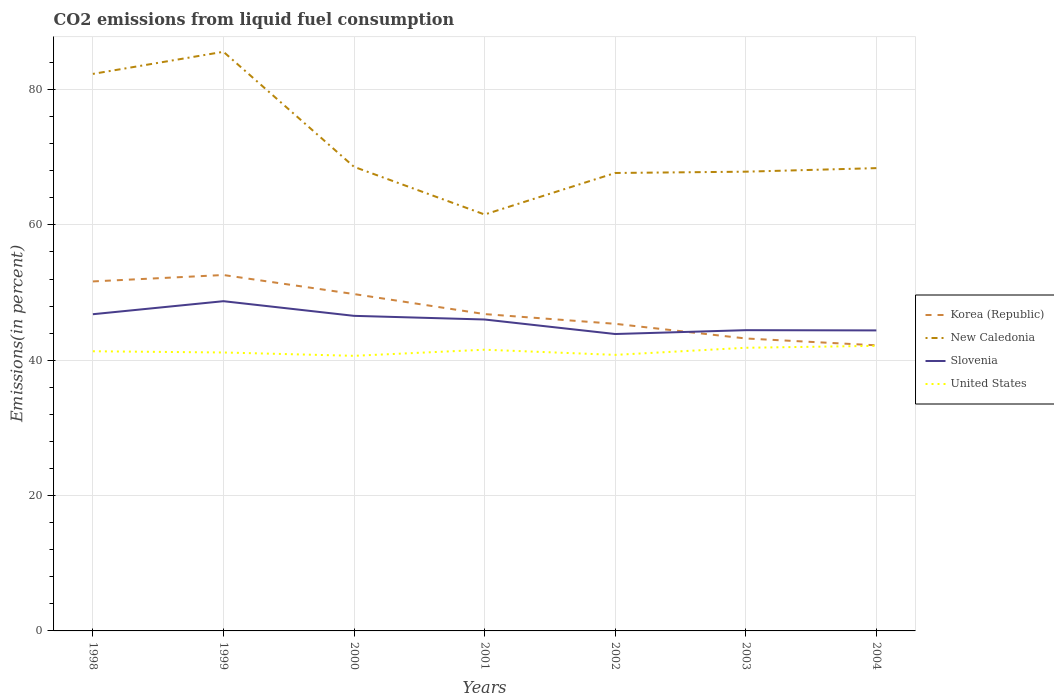Does the line corresponding to United States intersect with the line corresponding to New Caledonia?
Your answer should be compact. No. Is the number of lines equal to the number of legend labels?
Your answer should be very brief. Yes. Across all years, what is the maximum total CO2 emitted in Slovenia?
Make the answer very short. 43.88. What is the total total CO2 emitted in Slovenia in the graph?
Provide a short and direct response. 1.58. What is the difference between the highest and the second highest total CO2 emitted in Slovenia?
Offer a terse response. 4.85. What is the difference between the highest and the lowest total CO2 emitted in New Caledonia?
Offer a very short reply. 2. Is the total CO2 emitted in New Caledonia strictly greater than the total CO2 emitted in United States over the years?
Keep it short and to the point. No. Where does the legend appear in the graph?
Give a very brief answer. Center right. How are the legend labels stacked?
Your response must be concise. Vertical. What is the title of the graph?
Your answer should be compact. CO2 emissions from liquid fuel consumption. What is the label or title of the X-axis?
Provide a short and direct response. Years. What is the label or title of the Y-axis?
Provide a short and direct response. Emissions(in percent). What is the Emissions(in percent) of Korea (Republic) in 1998?
Make the answer very short. 51.65. What is the Emissions(in percent) in New Caledonia in 1998?
Provide a succinct answer. 82.32. What is the Emissions(in percent) of Slovenia in 1998?
Ensure brevity in your answer.  46.8. What is the Emissions(in percent) in United States in 1998?
Offer a terse response. 41.33. What is the Emissions(in percent) in Korea (Republic) in 1999?
Keep it short and to the point. 52.6. What is the Emissions(in percent) of New Caledonia in 1999?
Your answer should be very brief. 85.59. What is the Emissions(in percent) of Slovenia in 1999?
Your answer should be very brief. 48.73. What is the Emissions(in percent) of United States in 1999?
Provide a short and direct response. 41.15. What is the Emissions(in percent) of Korea (Republic) in 2000?
Ensure brevity in your answer.  49.78. What is the Emissions(in percent) of New Caledonia in 2000?
Provide a succinct answer. 68.58. What is the Emissions(in percent) of Slovenia in 2000?
Offer a very short reply. 46.56. What is the Emissions(in percent) of United States in 2000?
Provide a short and direct response. 40.65. What is the Emissions(in percent) in Korea (Republic) in 2001?
Offer a terse response. 46.82. What is the Emissions(in percent) in New Caledonia in 2001?
Ensure brevity in your answer.  61.54. What is the Emissions(in percent) in Slovenia in 2001?
Provide a short and direct response. 46.02. What is the Emissions(in percent) in United States in 2001?
Your answer should be compact. 41.56. What is the Emissions(in percent) in Korea (Republic) in 2002?
Provide a succinct answer. 45.38. What is the Emissions(in percent) of New Caledonia in 2002?
Make the answer very short. 67.67. What is the Emissions(in percent) of Slovenia in 2002?
Make the answer very short. 43.88. What is the Emissions(in percent) of United States in 2002?
Your answer should be very brief. 40.79. What is the Emissions(in percent) in Korea (Republic) in 2003?
Provide a succinct answer. 43.22. What is the Emissions(in percent) of New Caledonia in 2003?
Provide a short and direct response. 67.87. What is the Emissions(in percent) in Slovenia in 2003?
Give a very brief answer. 44.44. What is the Emissions(in percent) in United States in 2003?
Provide a short and direct response. 41.84. What is the Emissions(in percent) of Korea (Republic) in 2004?
Keep it short and to the point. 42.21. What is the Emissions(in percent) in New Caledonia in 2004?
Give a very brief answer. 68.39. What is the Emissions(in percent) of Slovenia in 2004?
Offer a very short reply. 44.41. What is the Emissions(in percent) of United States in 2004?
Provide a succinct answer. 42.13. Across all years, what is the maximum Emissions(in percent) of Korea (Republic)?
Keep it short and to the point. 52.6. Across all years, what is the maximum Emissions(in percent) of New Caledonia?
Offer a terse response. 85.59. Across all years, what is the maximum Emissions(in percent) in Slovenia?
Your answer should be very brief. 48.73. Across all years, what is the maximum Emissions(in percent) of United States?
Offer a terse response. 42.13. Across all years, what is the minimum Emissions(in percent) in Korea (Republic)?
Your answer should be very brief. 42.21. Across all years, what is the minimum Emissions(in percent) in New Caledonia?
Keep it short and to the point. 61.54. Across all years, what is the minimum Emissions(in percent) in Slovenia?
Ensure brevity in your answer.  43.88. Across all years, what is the minimum Emissions(in percent) in United States?
Make the answer very short. 40.65. What is the total Emissions(in percent) in Korea (Republic) in the graph?
Give a very brief answer. 331.66. What is the total Emissions(in percent) in New Caledonia in the graph?
Provide a short and direct response. 501.95. What is the total Emissions(in percent) of Slovenia in the graph?
Give a very brief answer. 320.84. What is the total Emissions(in percent) of United States in the graph?
Your answer should be very brief. 289.46. What is the difference between the Emissions(in percent) of Korea (Republic) in 1998 and that in 1999?
Offer a very short reply. -0.95. What is the difference between the Emissions(in percent) in New Caledonia in 1998 and that in 1999?
Your response must be concise. -3.27. What is the difference between the Emissions(in percent) of Slovenia in 1998 and that in 1999?
Offer a terse response. -1.93. What is the difference between the Emissions(in percent) in United States in 1998 and that in 1999?
Your answer should be compact. 0.18. What is the difference between the Emissions(in percent) of Korea (Republic) in 1998 and that in 2000?
Ensure brevity in your answer.  1.87. What is the difference between the Emissions(in percent) of New Caledonia in 1998 and that in 2000?
Provide a succinct answer. 13.74. What is the difference between the Emissions(in percent) of Slovenia in 1998 and that in 2000?
Offer a very short reply. 0.24. What is the difference between the Emissions(in percent) in United States in 1998 and that in 2000?
Ensure brevity in your answer.  0.67. What is the difference between the Emissions(in percent) in Korea (Republic) in 1998 and that in 2001?
Provide a short and direct response. 4.83. What is the difference between the Emissions(in percent) of New Caledonia in 1998 and that in 2001?
Your response must be concise. 20.78. What is the difference between the Emissions(in percent) of Slovenia in 1998 and that in 2001?
Your answer should be compact. 0.78. What is the difference between the Emissions(in percent) in United States in 1998 and that in 2001?
Offer a terse response. -0.23. What is the difference between the Emissions(in percent) of Korea (Republic) in 1998 and that in 2002?
Provide a short and direct response. 6.26. What is the difference between the Emissions(in percent) of New Caledonia in 1998 and that in 2002?
Offer a very short reply. 14.64. What is the difference between the Emissions(in percent) in Slovenia in 1998 and that in 2002?
Offer a very short reply. 2.93. What is the difference between the Emissions(in percent) in United States in 1998 and that in 2002?
Your response must be concise. 0.53. What is the difference between the Emissions(in percent) in Korea (Republic) in 1998 and that in 2003?
Your answer should be compact. 8.43. What is the difference between the Emissions(in percent) in New Caledonia in 1998 and that in 2003?
Ensure brevity in your answer.  14.45. What is the difference between the Emissions(in percent) in Slovenia in 1998 and that in 2003?
Ensure brevity in your answer.  2.36. What is the difference between the Emissions(in percent) of United States in 1998 and that in 2003?
Your response must be concise. -0.52. What is the difference between the Emissions(in percent) of Korea (Republic) in 1998 and that in 2004?
Your response must be concise. 9.44. What is the difference between the Emissions(in percent) of New Caledonia in 1998 and that in 2004?
Your answer should be very brief. 13.93. What is the difference between the Emissions(in percent) in Slovenia in 1998 and that in 2004?
Your answer should be compact. 2.39. What is the difference between the Emissions(in percent) in United States in 1998 and that in 2004?
Your response must be concise. -0.8. What is the difference between the Emissions(in percent) of Korea (Republic) in 1999 and that in 2000?
Offer a very short reply. 2.82. What is the difference between the Emissions(in percent) of New Caledonia in 1999 and that in 2000?
Keep it short and to the point. 17. What is the difference between the Emissions(in percent) of Slovenia in 1999 and that in 2000?
Provide a succinct answer. 2.17. What is the difference between the Emissions(in percent) in United States in 1999 and that in 2000?
Make the answer very short. 0.49. What is the difference between the Emissions(in percent) in Korea (Republic) in 1999 and that in 2001?
Offer a terse response. 5.77. What is the difference between the Emissions(in percent) in New Caledonia in 1999 and that in 2001?
Give a very brief answer. 24.05. What is the difference between the Emissions(in percent) in Slovenia in 1999 and that in 2001?
Provide a short and direct response. 2.71. What is the difference between the Emissions(in percent) in United States in 1999 and that in 2001?
Ensure brevity in your answer.  -0.41. What is the difference between the Emissions(in percent) in Korea (Republic) in 1999 and that in 2002?
Your response must be concise. 7.21. What is the difference between the Emissions(in percent) of New Caledonia in 1999 and that in 2002?
Your answer should be very brief. 17.91. What is the difference between the Emissions(in percent) in Slovenia in 1999 and that in 2002?
Give a very brief answer. 4.85. What is the difference between the Emissions(in percent) in United States in 1999 and that in 2002?
Keep it short and to the point. 0.35. What is the difference between the Emissions(in percent) of Korea (Republic) in 1999 and that in 2003?
Your answer should be compact. 9.38. What is the difference between the Emissions(in percent) of New Caledonia in 1999 and that in 2003?
Give a very brief answer. 17.72. What is the difference between the Emissions(in percent) of Slovenia in 1999 and that in 2003?
Your answer should be very brief. 4.28. What is the difference between the Emissions(in percent) of United States in 1999 and that in 2003?
Your answer should be compact. -0.7. What is the difference between the Emissions(in percent) of Korea (Republic) in 1999 and that in 2004?
Provide a succinct answer. 10.39. What is the difference between the Emissions(in percent) of New Caledonia in 1999 and that in 2004?
Make the answer very short. 17.19. What is the difference between the Emissions(in percent) in Slovenia in 1999 and that in 2004?
Your response must be concise. 4.32. What is the difference between the Emissions(in percent) in United States in 1999 and that in 2004?
Keep it short and to the point. -0.98. What is the difference between the Emissions(in percent) of Korea (Republic) in 2000 and that in 2001?
Give a very brief answer. 2.96. What is the difference between the Emissions(in percent) in New Caledonia in 2000 and that in 2001?
Your response must be concise. 7.04. What is the difference between the Emissions(in percent) in Slovenia in 2000 and that in 2001?
Ensure brevity in your answer.  0.54. What is the difference between the Emissions(in percent) in United States in 2000 and that in 2001?
Your answer should be very brief. -0.9. What is the difference between the Emissions(in percent) of Korea (Republic) in 2000 and that in 2002?
Your response must be concise. 4.4. What is the difference between the Emissions(in percent) in New Caledonia in 2000 and that in 2002?
Your answer should be very brief. 0.91. What is the difference between the Emissions(in percent) of Slovenia in 2000 and that in 2002?
Ensure brevity in your answer.  2.69. What is the difference between the Emissions(in percent) in United States in 2000 and that in 2002?
Offer a very short reply. -0.14. What is the difference between the Emissions(in percent) of Korea (Republic) in 2000 and that in 2003?
Provide a short and direct response. 6.56. What is the difference between the Emissions(in percent) of New Caledonia in 2000 and that in 2003?
Offer a terse response. 0.71. What is the difference between the Emissions(in percent) in Slovenia in 2000 and that in 2003?
Your response must be concise. 2.12. What is the difference between the Emissions(in percent) of United States in 2000 and that in 2003?
Keep it short and to the point. -1.19. What is the difference between the Emissions(in percent) in Korea (Republic) in 2000 and that in 2004?
Keep it short and to the point. 7.57. What is the difference between the Emissions(in percent) in New Caledonia in 2000 and that in 2004?
Provide a short and direct response. 0.19. What is the difference between the Emissions(in percent) in Slovenia in 2000 and that in 2004?
Provide a succinct answer. 2.15. What is the difference between the Emissions(in percent) of United States in 2000 and that in 2004?
Make the answer very short. -1.48. What is the difference between the Emissions(in percent) in Korea (Republic) in 2001 and that in 2002?
Your answer should be compact. 1.44. What is the difference between the Emissions(in percent) of New Caledonia in 2001 and that in 2002?
Provide a succinct answer. -6.14. What is the difference between the Emissions(in percent) of Slovenia in 2001 and that in 2002?
Offer a very short reply. 2.15. What is the difference between the Emissions(in percent) of United States in 2001 and that in 2002?
Offer a very short reply. 0.76. What is the difference between the Emissions(in percent) in Korea (Republic) in 2001 and that in 2003?
Offer a very short reply. 3.6. What is the difference between the Emissions(in percent) of New Caledonia in 2001 and that in 2003?
Offer a very short reply. -6.33. What is the difference between the Emissions(in percent) in Slovenia in 2001 and that in 2003?
Your answer should be compact. 1.58. What is the difference between the Emissions(in percent) in United States in 2001 and that in 2003?
Make the answer very short. -0.29. What is the difference between the Emissions(in percent) of Korea (Republic) in 2001 and that in 2004?
Offer a terse response. 4.61. What is the difference between the Emissions(in percent) of New Caledonia in 2001 and that in 2004?
Provide a succinct answer. -6.85. What is the difference between the Emissions(in percent) of Slovenia in 2001 and that in 2004?
Make the answer very short. 1.61. What is the difference between the Emissions(in percent) of United States in 2001 and that in 2004?
Make the answer very short. -0.57. What is the difference between the Emissions(in percent) in Korea (Republic) in 2002 and that in 2003?
Make the answer very short. 2.17. What is the difference between the Emissions(in percent) in New Caledonia in 2002 and that in 2003?
Keep it short and to the point. -0.19. What is the difference between the Emissions(in percent) of Slovenia in 2002 and that in 2003?
Offer a very short reply. -0.57. What is the difference between the Emissions(in percent) of United States in 2002 and that in 2003?
Offer a terse response. -1.05. What is the difference between the Emissions(in percent) in Korea (Republic) in 2002 and that in 2004?
Give a very brief answer. 3.18. What is the difference between the Emissions(in percent) of New Caledonia in 2002 and that in 2004?
Provide a succinct answer. -0.72. What is the difference between the Emissions(in percent) of Slovenia in 2002 and that in 2004?
Provide a short and direct response. -0.53. What is the difference between the Emissions(in percent) of United States in 2002 and that in 2004?
Ensure brevity in your answer.  -1.34. What is the difference between the Emissions(in percent) in New Caledonia in 2003 and that in 2004?
Ensure brevity in your answer.  -0.52. What is the difference between the Emissions(in percent) of Slovenia in 2003 and that in 2004?
Your response must be concise. 0.03. What is the difference between the Emissions(in percent) in United States in 2003 and that in 2004?
Offer a terse response. -0.29. What is the difference between the Emissions(in percent) of Korea (Republic) in 1998 and the Emissions(in percent) of New Caledonia in 1999?
Provide a succinct answer. -33.94. What is the difference between the Emissions(in percent) of Korea (Republic) in 1998 and the Emissions(in percent) of Slovenia in 1999?
Make the answer very short. 2.92. What is the difference between the Emissions(in percent) in Korea (Republic) in 1998 and the Emissions(in percent) in United States in 1999?
Provide a short and direct response. 10.5. What is the difference between the Emissions(in percent) of New Caledonia in 1998 and the Emissions(in percent) of Slovenia in 1999?
Provide a short and direct response. 33.59. What is the difference between the Emissions(in percent) in New Caledonia in 1998 and the Emissions(in percent) in United States in 1999?
Give a very brief answer. 41.17. What is the difference between the Emissions(in percent) of Slovenia in 1998 and the Emissions(in percent) of United States in 1999?
Your answer should be compact. 5.65. What is the difference between the Emissions(in percent) of Korea (Republic) in 1998 and the Emissions(in percent) of New Caledonia in 2000?
Offer a terse response. -16.93. What is the difference between the Emissions(in percent) in Korea (Republic) in 1998 and the Emissions(in percent) in Slovenia in 2000?
Your response must be concise. 5.09. What is the difference between the Emissions(in percent) of Korea (Republic) in 1998 and the Emissions(in percent) of United States in 2000?
Provide a succinct answer. 10.99. What is the difference between the Emissions(in percent) in New Caledonia in 1998 and the Emissions(in percent) in Slovenia in 2000?
Give a very brief answer. 35.76. What is the difference between the Emissions(in percent) in New Caledonia in 1998 and the Emissions(in percent) in United States in 2000?
Your response must be concise. 41.66. What is the difference between the Emissions(in percent) in Slovenia in 1998 and the Emissions(in percent) in United States in 2000?
Keep it short and to the point. 6.15. What is the difference between the Emissions(in percent) of Korea (Republic) in 1998 and the Emissions(in percent) of New Caledonia in 2001?
Keep it short and to the point. -9.89. What is the difference between the Emissions(in percent) in Korea (Republic) in 1998 and the Emissions(in percent) in Slovenia in 2001?
Provide a succinct answer. 5.63. What is the difference between the Emissions(in percent) of Korea (Republic) in 1998 and the Emissions(in percent) of United States in 2001?
Offer a terse response. 10.09. What is the difference between the Emissions(in percent) of New Caledonia in 1998 and the Emissions(in percent) of Slovenia in 2001?
Keep it short and to the point. 36.3. What is the difference between the Emissions(in percent) in New Caledonia in 1998 and the Emissions(in percent) in United States in 2001?
Provide a short and direct response. 40.76. What is the difference between the Emissions(in percent) of Slovenia in 1998 and the Emissions(in percent) of United States in 2001?
Your answer should be compact. 5.24. What is the difference between the Emissions(in percent) of Korea (Republic) in 1998 and the Emissions(in percent) of New Caledonia in 2002?
Provide a short and direct response. -16.02. What is the difference between the Emissions(in percent) in Korea (Republic) in 1998 and the Emissions(in percent) in Slovenia in 2002?
Your response must be concise. 7.77. What is the difference between the Emissions(in percent) in Korea (Republic) in 1998 and the Emissions(in percent) in United States in 2002?
Keep it short and to the point. 10.85. What is the difference between the Emissions(in percent) of New Caledonia in 1998 and the Emissions(in percent) of Slovenia in 2002?
Give a very brief answer. 38.44. What is the difference between the Emissions(in percent) of New Caledonia in 1998 and the Emissions(in percent) of United States in 2002?
Provide a succinct answer. 41.52. What is the difference between the Emissions(in percent) in Slovenia in 1998 and the Emissions(in percent) in United States in 2002?
Give a very brief answer. 6.01. What is the difference between the Emissions(in percent) in Korea (Republic) in 1998 and the Emissions(in percent) in New Caledonia in 2003?
Offer a very short reply. -16.22. What is the difference between the Emissions(in percent) in Korea (Republic) in 1998 and the Emissions(in percent) in Slovenia in 2003?
Your answer should be very brief. 7.2. What is the difference between the Emissions(in percent) in Korea (Republic) in 1998 and the Emissions(in percent) in United States in 2003?
Ensure brevity in your answer.  9.8. What is the difference between the Emissions(in percent) of New Caledonia in 1998 and the Emissions(in percent) of Slovenia in 2003?
Offer a terse response. 37.87. What is the difference between the Emissions(in percent) of New Caledonia in 1998 and the Emissions(in percent) of United States in 2003?
Make the answer very short. 40.47. What is the difference between the Emissions(in percent) of Slovenia in 1998 and the Emissions(in percent) of United States in 2003?
Provide a succinct answer. 4.96. What is the difference between the Emissions(in percent) in Korea (Republic) in 1998 and the Emissions(in percent) in New Caledonia in 2004?
Keep it short and to the point. -16.74. What is the difference between the Emissions(in percent) in Korea (Republic) in 1998 and the Emissions(in percent) in Slovenia in 2004?
Offer a very short reply. 7.24. What is the difference between the Emissions(in percent) in Korea (Republic) in 1998 and the Emissions(in percent) in United States in 2004?
Provide a succinct answer. 9.52. What is the difference between the Emissions(in percent) of New Caledonia in 1998 and the Emissions(in percent) of Slovenia in 2004?
Your answer should be compact. 37.91. What is the difference between the Emissions(in percent) in New Caledonia in 1998 and the Emissions(in percent) in United States in 2004?
Your answer should be compact. 40.19. What is the difference between the Emissions(in percent) of Slovenia in 1998 and the Emissions(in percent) of United States in 2004?
Ensure brevity in your answer.  4.67. What is the difference between the Emissions(in percent) in Korea (Republic) in 1999 and the Emissions(in percent) in New Caledonia in 2000?
Your response must be concise. -15.98. What is the difference between the Emissions(in percent) in Korea (Republic) in 1999 and the Emissions(in percent) in Slovenia in 2000?
Provide a short and direct response. 6.03. What is the difference between the Emissions(in percent) of Korea (Republic) in 1999 and the Emissions(in percent) of United States in 2000?
Offer a terse response. 11.94. What is the difference between the Emissions(in percent) of New Caledonia in 1999 and the Emissions(in percent) of Slovenia in 2000?
Give a very brief answer. 39.02. What is the difference between the Emissions(in percent) of New Caledonia in 1999 and the Emissions(in percent) of United States in 2000?
Your answer should be very brief. 44.93. What is the difference between the Emissions(in percent) in Slovenia in 1999 and the Emissions(in percent) in United States in 2000?
Offer a terse response. 8.07. What is the difference between the Emissions(in percent) of Korea (Republic) in 1999 and the Emissions(in percent) of New Caledonia in 2001?
Your response must be concise. -8.94. What is the difference between the Emissions(in percent) in Korea (Republic) in 1999 and the Emissions(in percent) in Slovenia in 2001?
Keep it short and to the point. 6.57. What is the difference between the Emissions(in percent) of Korea (Republic) in 1999 and the Emissions(in percent) of United States in 2001?
Your answer should be very brief. 11.04. What is the difference between the Emissions(in percent) of New Caledonia in 1999 and the Emissions(in percent) of Slovenia in 2001?
Provide a short and direct response. 39.56. What is the difference between the Emissions(in percent) of New Caledonia in 1999 and the Emissions(in percent) of United States in 2001?
Provide a short and direct response. 44.03. What is the difference between the Emissions(in percent) of Slovenia in 1999 and the Emissions(in percent) of United States in 2001?
Offer a very short reply. 7.17. What is the difference between the Emissions(in percent) in Korea (Republic) in 1999 and the Emissions(in percent) in New Caledonia in 2002?
Give a very brief answer. -15.08. What is the difference between the Emissions(in percent) in Korea (Republic) in 1999 and the Emissions(in percent) in Slovenia in 2002?
Your answer should be very brief. 8.72. What is the difference between the Emissions(in percent) in Korea (Republic) in 1999 and the Emissions(in percent) in United States in 2002?
Provide a short and direct response. 11.8. What is the difference between the Emissions(in percent) in New Caledonia in 1999 and the Emissions(in percent) in Slovenia in 2002?
Provide a short and direct response. 41.71. What is the difference between the Emissions(in percent) of New Caledonia in 1999 and the Emissions(in percent) of United States in 2002?
Your answer should be very brief. 44.79. What is the difference between the Emissions(in percent) in Slovenia in 1999 and the Emissions(in percent) in United States in 2002?
Offer a terse response. 7.93. What is the difference between the Emissions(in percent) in Korea (Republic) in 1999 and the Emissions(in percent) in New Caledonia in 2003?
Offer a terse response. -15.27. What is the difference between the Emissions(in percent) of Korea (Republic) in 1999 and the Emissions(in percent) of Slovenia in 2003?
Provide a short and direct response. 8.15. What is the difference between the Emissions(in percent) of Korea (Republic) in 1999 and the Emissions(in percent) of United States in 2003?
Offer a very short reply. 10.75. What is the difference between the Emissions(in percent) of New Caledonia in 1999 and the Emissions(in percent) of Slovenia in 2003?
Offer a very short reply. 41.14. What is the difference between the Emissions(in percent) in New Caledonia in 1999 and the Emissions(in percent) in United States in 2003?
Provide a short and direct response. 43.74. What is the difference between the Emissions(in percent) in Slovenia in 1999 and the Emissions(in percent) in United States in 2003?
Offer a terse response. 6.88. What is the difference between the Emissions(in percent) in Korea (Republic) in 1999 and the Emissions(in percent) in New Caledonia in 2004?
Offer a very short reply. -15.79. What is the difference between the Emissions(in percent) of Korea (Republic) in 1999 and the Emissions(in percent) of Slovenia in 2004?
Your answer should be compact. 8.19. What is the difference between the Emissions(in percent) of Korea (Republic) in 1999 and the Emissions(in percent) of United States in 2004?
Provide a short and direct response. 10.47. What is the difference between the Emissions(in percent) in New Caledonia in 1999 and the Emissions(in percent) in Slovenia in 2004?
Provide a short and direct response. 41.17. What is the difference between the Emissions(in percent) of New Caledonia in 1999 and the Emissions(in percent) of United States in 2004?
Make the answer very short. 43.46. What is the difference between the Emissions(in percent) in Slovenia in 1999 and the Emissions(in percent) in United States in 2004?
Make the answer very short. 6.6. What is the difference between the Emissions(in percent) in Korea (Republic) in 2000 and the Emissions(in percent) in New Caledonia in 2001?
Keep it short and to the point. -11.76. What is the difference between the Emissions(in percent) in Korea (Republic) in 2000 and the Emissions(in percent) in Slovenia in 2001?
Your response must be concise. 3.76. What is the difference between the Emissions(in percent) in Korea (Republic) in 2000 and the Emissions(in percent) in United States in 2001?
Make the answer very short. 8.22. What is the difference between the Emissions(in percent) of New Caledonia in 2000 and the Emissions(in percent) of Slovenia in 2001?
Offer a terse response. 22.56. What is the difference between the Emissions(in percent) of New Caledonia in 2000 and the Emissions(in percent) of United States in 2001?
Offer a very short reply. 27.02. What is the difference between the Emissions(in percent) in Slovenia in 2000 and the Emissions(in percent) in United States in 2001?
Your response must be concise. 5. What is the difference between the Emissions(in percent) in Korea (Republic) in 2000 and the Emissions(in percent) in New Caledonia in 2002?
Your answer should be very brief. -17.89. What is the difference between the Emissions(in percent) of Korea (Republic) in 2000 and the Emissions(in percent) of Slovenia in 2002?
Offer a terse response. 5.9. What is the difference between the Emissions(in percent) in Korea (Republic) in 2000 and the Emissions(in percent) in United States in 2002?
Keep it short and to the point. 8.99. What is the difference between the Emissions(in percent) in New Caledonia in 2000 and the Emissions(in percent) in Slovenia in 2002?
Offer a very short reply. 24.7. What is the difference between the Emissions(in percent) in New Caledonia in 2000 and the Emissions(in percent) in United States in 2002?
Your answer should be very brief. 27.79. What is the difference between the Emissions(in percent) in Slovenia in 2000 and the Emissions(in percent) in United States in 2002?
Ensure brevity in your answer.  5.77. What is the difference between the Emissions(in percent) of Korea (Republic) in 2000 and the Emissions(in percent) of New Caledonia in 2003?
Your answer should be compact. -18.09. What is the difference between the Emissions(in percent) of Korea (Republic) in 2000 and the Emissions(in percent) of Slovenia in 2003?
Keep it short and to the point. 5.34. What is the difference between the Emissions(in percent) of Korea (Republic) in 2000 and the Emissions(in percent) of United States in 2003?
Your answer should be very brief. 7.94. What is the difference between the Emissions(in percent) in New Caledonia in 2000 and the Emissions(in percent) in Slovenia in 2003?
Offer a very short reply. 24.14. What is the difference between the Emissions(in percent) of New Caledonia in 2000 and the Emissions(in percent) of United States in 2003?
Offer a very short reply. 26.74. What is the difference between the Emissions(in percent) of Slovenia in 2000 and the Emissions(in percent) of United States in 2003?
Offer a very short reply. 4.72. What is the difference between the Emissions(in percent) of Korea (Republic) in 2000 and the Emissions(in percent) of New Caledonia in 2004?
Offer a terse response. -18.61. What is the difference between the Emissions(in percent) of Korea (Republic) in 2000 and the Emissions(in percent) of Slovenia in 2004?
Offer a terse response. 5.37. What is the difference between the Emissions(in percent) in Korea (Republic) in 2000 and the Emissions(in percent) in United States in 2004?
Give a very brief answer. 7.65. What is the difference between the Emissions(in percent) in New Caledonia in 2000 and the Emissions(in percent) in Slovenia in 2004?
Offer a very short reply. 24.17. What is the difference between the Emissions(in percent) in New Caledonia in 2000 and the Emissions(in percent) in United States in 2004?
Provide a succinct answer. 26.45. What is the difference between the Emissions(in percent) in Slovenia in 2000 and the Emissions(in percent) in United States in 2004?
Your response must be concise. 4.43. What is the difference between the Emissions(in percent) in Korea (Republic) in 2001 and the Emissions(in percent) in New Caledonia in 2002?
Ensure brevity in your answer.  -20.85. What is the difference between the Emissions(in percent) of Korea (Republic) in 2001 and the Emissions(in percent) of Slovenia in 2002?
Your answer should be very brief. 2.94. What is the difference between the Emissions(in percent) in Korea (Republic) in 2001 and the Emissions(in percent) in United States in 2002?
Ensure brevity in your answer.  6.03. What is the difference between the Emissions(in percent) in New Caledonia in 2001 and the Emissions(in percent) in Slovenia in 2002?
Keep it short and to the point. 17.66. What is the difference between the Emissions(in percent) in New Caledonia in 2001 and the Emissions(in percent) in United States in 2002?
Offer a very short reply. 20.74. What is the difference between the Emissions(in percent) of Slovenia in 2001 and the Emissions(in percent) of United States in 2002?
Make the answer very short. 5.23. What is the difference between the Emissions(in percent) of Korea (Republic) in 2001 and the Emissions(in percent) of New Caledonia in 2003?
Provide a succinct answer. -21.05. What is the difference between the Emissions(in percent) of Korea (Republic) in 2001 and the Emissions(in percent) of Slovenia in 2003?
Your answer should be very brief. 2.38. What is the difference between the Emissions(in percent) in Korea (Republic) in 2001 and the Emissions(in percent) in United States in 2003?
Your answer should be compact. 4.98. What is the difference between the Emissions(in percent) of New Caledonia in 2001 and the Emissions(in percent) of Slovenia in 2003?
Provide a succinct answer. 17.09. What is the difference between the Emissions(in percent) of New Caledonia in 2001 and the Emissions(in percent) of United States in 2003?
Offer a very short reply. 19.69. What is the difference between the Emissions(in percent) in Slovenia in 2001 and the Emissions(in percent) in United States in 2003?
Offer a very short reply. 4.18. What is the difference between the Emissions(in percent) of Korea (Republic) in 2001 and the Emissions(in percent) of New Caledonia in 2004?
Your response must be concise. -21.57. What is the difference between the Emissions(in percent) in Korea (Republic) in 2001 and the Emissions(in percent) in Slovenia in 2004?
Keep it short and to the point. 2.41. What is the difference between the Emissions(in percent) in Korea (Republic) in 2001 and the Emissions(in percent) in United States in 2004?
Make the answer very short. 4.69. What is the difference between the Emissions(in percent) in New Caledonia in 2001 and the Emissions(in percent) in Slovenia in 2004?
Offer a very short reply. 17.13. What is the difference between the Emissions(in percent) of New Caledonia in 2001 and the Emissions(in percent) of United States in 2004?
Offer a terse response. 19.41. What is the difference between the Emissions(in percent) of Slovenia in 2001 and the Emissions(in percent) of United States in 2004?
Your response must be concise. 3.89. What is the difference between the Emissions(in percent) of Korea (Republic) in 2002 and the Emissions(in percent) of New Caledonia in 2003?
Offer a terse response. -22.48. What is the difference between the Emissions(in percent) in Korea (Republic) in 2002 and the Emissions(in percent) in Slovenia in 2003?
Your answer should be very brief. 0.94. What is the difference between the Emissions(in percent) of Korea (Republic) in 2002 and the Emissions(in percent) of United States in 2003?
Ensure brevity in your answer.  3.54. What is the difference between the Emissions(in percent) of New Caledonia in 2002 and the Emissions(in percent) of Slovenia in 2003?
Keep it short and to the point. 23.23. What is the difference between the Emissions(in percent) in New Caledonia in 2002 and the Emissions(in percent) in United States in 2003?
Provide a short and direct response. 25.83. What is the difference between the Emissions(in percent) of Slovenia in 2002 and the Emissions(in percent) of United States in 2003?
Keep it short and to the point. 2.03. What is the difference between the Emissions(in percent) in Korea (Republic) in 2002 and the Emissions(in percent) in New Caledonia in 2004?
Your answer should be compact. -23.01. What is the difference between the Emissions(in percent) of Korea (Republic) in 2002 and the Emissions(in percent) of Slovenia in 2004?
Keep it short and to the point. 0.97. What is the difference between the Emissions(in percent) in Korea (Republic) in 2002 and the Emissions(in percent) in United States in 2004?
Keep it short and to the point. 3.25. What is the difference between the Emissions(in percent) in New Caledonia in 2002 and the Emissions(in percent) in Slovenia in 2004?
Your answer should be compact. 23.26. What is the difference between the Emissions(in percent) of New Caledonia in 2002 and the Emissions(in percent) of United States in 2004?
Keep it short and to the point. 25.54. What is the difference between the Emissions(in percent) of Slovenia in 2002 and the Emissions(in percent) of United States in 2004?
Your answer should be very brief. 1.75. What is the difference between the Emissions(in percent) of Korea (Republic) in 2003 and the Emissions(in percent) of New Caledonia in 2004?
Give a very brief answer. -25.17. What is the difference between the Emissions(in percent) of Korea (Republic) in 2003 and the Emissions(in percent) of Slovenia in 2004?
Offer a very short reply. -1.19. What is the difference between the Emissions(in percent) in Korea (Republic) in 2003 and the Emissions(in percent) in United States in 2004?
Provide a succinct answer. 1.09. What is the difference between the Emissions(in percent) in New Caledonia in 2003 and the Emissions(in percent) in Slovenia in 2004?
Provide a succinct answer. 23.46. What is the difference between the Emissions(in percent) in New Caledonia in 2003 and the Emissions(in percent) in United States in 2004?
Provide a short and direct response. 25.74. What is the difference between the Emissions(in percent) in Slovenia in 2003 and the Emissions(in percent) in United States in 2004?
Offer a very short reply. 2.31. What is the average Emissions(in percent) of Korea (Republic) per year?
Give a very brief answer. 47.38. What is the average Emissions(in percent) in New Caledonia per year?
Keep it short and to the point. 71.71. What is the average Emissions(in percent) in Slovenia per year?
Your response must be concise. 45.83. What is the average Emissions(in percent) in United States per year?
Your answer should be compact. 41.35. In the year 1998, what is the difference between the Emissions(in percent) of Korea (Republic) and Emissions(in percent) of New Caledonia?
Give a very brief answer. -30.67. In the year 1998, what is the difference between the Emissions(in percent) of Korea (Republic) and Emissions(in percent) of Slovenia?
Your answer should be very brief. 4.85. In the year 1998, what is the difference between the Emissions(in percent) of Korea (Republic) and Emissions(in percent) of United States?
Ensure brevity in your answer.  10.32. In the year 1998, what is the difference between the Emissions(in percent) of New Caledonia and Emissions(in percent) of Slovenia?
Offer a terse response. 35.52. In the year 1998, what is the difference between the Emissions(in percent) of New Caledonia and Emissions(in percent) of United States?
Keep it short and to the point. 40.99. In the year 1998, what is the difference between the Emissions(in percent) of Slovenia and Emissions(in percent) of United States?
Provide a succinct answer. 5.47. In the year 1999, what is the difference between the Emissions(in percent) in Korea (Republic) and Emissions(in percent) in New Caledonia?
Keep it short and to the point. -32.99. In the year 1999, what is the difference between the Emissions(in percent) in Korea (Republic) and Emissions(in percent) in Slovenia?
Make the answer very short. 3.87. In the year 1999, what is the difference between the Emissions(in percent) of Korea (Republic) and Emissions(in percent) of United States?
Provide a short and direct response. 11.45. In the year 1999, what is the difference between the Emissions(in percent) of New Caledonia and Emissions(in percent) of Slovenia?
Offer a very short reply. 36.86. In the year 1999, what is the difference between the Emissions(in percent) of New Caledonia and Emissions(in percent) of United States?
Offer a very short reply. 44.44. In the year 1999, what is the difference between the Emissions(in percent) of Slovenia and Emissions(in percent) of United States?
Make the answer very short. 7.58. In the year 2000, what is the difference between the Emissions(in percent) of Korea (Republic) and Emissions(in percent) of New Caledonia?
Your response must be concise. -18.8. In the year 2000, what is the difference between the Emissions(in percent) in Korea (Republic) and Emissions(in percent) in Slovenia?
Keep it short and to the point. 3.22. In the year 2000, what is the difference between the Emissions(in percent) of Korea (Republic) and Emissions(in percent) of United States?
Provide a succinct answer. 9.13. In the year 2000, what is the difference between the Emissions(in percent) in New Caledonia and Emissions(in percent) in Slovenia?
Your response must be concise. 22.02. In the year 2000, what is the difference between the Emissions(in percent) in New Caledonia and Emissions(in percent) in United States?
Your answer should be very brief. 27.93. In the year 2000, what is the difference between the Emissions(in percent) of Slovenia and Emissions(in percent) of United States?
Provide a short and direct response. 5.91. In the year 2001, what is the difference between the Emissions(in percent) of Korea (Republic) and Emissions(in percent) of New Caledonia?
Offer a terse response. -14.72. In the year 2001, what is the difference between the Emissions(in percent) of Korea (Republic) and Emissions(in percent) of Slovenia?
Give a very brief answer. 0.8. In the year 2001, what is the difference between the Emissions(in percent) in Korea (Republic) and Emissions(in percent) in United States?
Make the answer very short. 5.26. In the year 2001, what is the difference between the Emissions(in percent) in New Caledonia and Emissions(in percent) in Slovenia?
Your answer should be very brief. 15.52. In the year 2001, what is the difference between the Emissions(in percent) in New Caledonia and Emissions(in percent) in United States?
Provide a succinct answer. 19.98. In the year 2001, what is the difference between the Emissions(in percent) of Slovenia and Emissions(in percent) of United States?
Your answer should be very brief. 4.46. In the year 2002, what is the difference between the Emissions(in percent) in Korea (Republic) and Emissions(in percent) in New Caledonia?
Offer a terse response. -22.29. In the year 2002, what is the difference between the Emissions(in percent) in Korea (Republic) and Emissions(in percent) in Slovenia?
Your answer should be very brief. 1.51. In the year 2002, what is the difference between the Emissions(in percent) in Korea (Republic) and Emissions(in percent) in United States?
Ensure brevity in your answer.  4.59. In the year 2002, what is the difference between the Emissions(in percent) of New Caledonia and Emissions(in percent) of Slovenia?
Offer a very short reply. 23.8. In the year 2002, what is the difference between the Emissions(in percent) of New Caledonia and Emissions(in percent) of United States?
Give a very brief answer. 26.88. In the year 2002, what is the difference between the Emissions(in percent) in Slovenia and Emissions(in percent) in United States?
Your answer should be very brief. 3.08. In the year 2003, what is the difference between the Emissions(in percent) of Korea (Republic) and Emissions(in percent) of New Caledonia?
Give a very brief answer. -24.65. In the year 2003, what is the difference between the Emissions(in percent) of Korea (Republic) and Emissions(in percent) of Slovenia?
Give a very brief answer. -1.23. In the year 2003, what is the difference between the Emissions(in percent) in Korea (Republic) and Emissions(in percent) in United States?
Offer a very short reply. 1.37. In the year 2003, what is the difference between the Emissions(in percent) in New Caledonia and Emissions(in percent) in Slovenia?
Ensure brevity in your answer.  23.42. In the year 2003, what is the difference between the Emissions(in percent) of New Caledonia and Emissions(in percent) of United States?
Offer a terse response. 26.02. In the year 2003, what is the difference between the Emissions(in percent) in Slovenia and Emissions(in percent) in United States?
Keep it short and to the point. 2.6. In the year 2004, what is the difference between the Emissions(in percent) of Korea (Republic) and Emissions(in percent) of New Caledonia?
Your answer should be very brief. -26.18. In the year 2004, what is the difference between the Emissions(in percent) of Korea (Republic) and Emissions(in percent) of Slovenia?
Provide a short and direct response. -2.2. In the year 2004, what is the difference between the Emissions(in percent) in Korea (Republic) and Emissions(in percent) in United States?
Offer a very short reply. 0.08. In the year 2004, what is the difference between the Emissions(in percent) in New Caledonia and Emissions(in percent) in Slovenia?
Give a very brief answer. 23.98. In the year 2004, what is the difference between the Emissions(in percent) of New Caledonia and Emissions(in percent) of United States?
Your answer should be very brief. 26.26. In the year 2004, what is the difference between the Emissions(in percent) in Slovenia and Emissions(in percent) in United States?
Offer a very short reply. 2.28. What is the ratio of the Emissions(in percent) of Korea (Republic) in 1998 to that in 1999?
Provide a short and direct response. 0.98. What is the ratio of the Emissions(in percent) of New Caledonia in 1998 to that in 1999?
Keep it short and to the point. 0.96. What is the ratio of the Emissions(in percent) of Slovenia in 1998 to that in 1999?
Keep it short and to the point. 0.96. What is the ratio of the Emissions(in percent) of United States in 1998 to that in 1999?
Keep it short and to the point. 1. What is the ratio of the Emissions(in percent) of Korea (Republic) in 1998 to that in 2000?
Your answer should be very brief. 1.04. What is the ratio of the Emissions(in percent) of New Caledonia in 1998 to that in 2000?
Your answer should be very brief. 1.2. What is the ratio of the Emissions(in percent) in United States in 1998 to that in 2000?
Your response must be concise. 1.02. What is the ratio of the Emissions(in percent) of Korea (Republic) in 1998 to that in 2001?
Give a very brief answer. 1.1. What is the ratio of the Emissions(in percent) in New Caledonia in 1998 to that in 2001?
Offer a terse response. 1.34. What is the ratio of the Emissions(in percent) of Korea (Republic) in 1998 to that in 2002?
Ensure brevity in your answer.  1.14. What is the ratio of the Emissions(in percent) of New Caledonia in 1998 to that in 2002?
Give a very brief answer. 1.22. What is the ratio of the Emissions(in percent) in Slovenia in 1998 to that in 2002?
Offer a terse response. 1.07. What is the ratio of the Emissions(in percent) of United States in 1998 to that in 2002?
Offer a terse response. 1.01. What is the ratio of the Emissions(in percent) of Korea (Republic) in 1998 to that in 2003?
Ensure brevity in your answer.  1.2. What is the ratio of the Emissions(in percent) in New Caledonia in 1998 to that in 2003?
Provide a short and direct response. 1.21. What is the ratio of the Emissions(in percent) of Slovenia in 1998 to that in 2003?
Keep it short and to the point. 1.05. What is the ratio of the Emissions(in percent) in United States in 1998 to that in 2003?
Offer a terse response. 0.99. What is the ratio of the Emissions(in percent) in Korea (Republic) in 1998 to that in 2004?
Make the answer very short. 1.22. What is the ratio of the Emissions(in percent) of New Caledonia in 1998 to that in 2004?
Your answer should be compact. 1.2. What is the ratio of the Emissions(in percent) of Slovenia in 1998 to that in 2004?
Offer a very short reply. 1.05. What is the ratio of the Emissions(in percent) in Korea (Republic) in 1999 to that in 2000?
Offer a very short reply. 1.06. What is the ratio of the Emissions(in percent) of New Caledonia in 1999 to that in 2000?
Your response must be concise. 1.25. What is the ratio of the Emissions(in percent) in Slovenia in 1999 to that in 2000?
Offer a terse response. 1.05. What is the ratio of the Emissions(in percent) in United States in 1999 to that in 2000?
Make the answer very short. 1.01. What is the ratio of the Emissions(in percent) of Korea (Republic) in 1999 to that in 2001?
Your response must be concise. 1.12. What is the ratio of the Emissions(in percent) of New Caledonia in 1999 to that in 2001?
Offer a terse response. 1.39. What is the ratio of the Emissions(in percent) of Slovenia in 1999 to that in 2001?
Provide a short and direct response. 1.06. What is the ratio of the Emissions(in percent) of Korea (Republic) in 1999 to that in 2002?
Keep it short and to the point. 1.16. What is the ratio of the Emissions(in percent) of New Caledonia in 1999 to that in 2002?
Provide a short and direct response. 1.26. What is the ratio of the Emissions(in percent) of Slovenia in 1999 to that in 2002?
Give a very brief answer. 1.11. What is the ratio of the Emissions(in percent) of United States in 1999 to that in 2002?
Provide a succinct answer. 1.01. What is the ratio of the Emissions(in percent) of Korea (Republic) in 1999 to that in 2003?
Keep it short and to the point. 1.22. What is the ratio of the Emissions(in percent) of New Caledonia in 1999 to that in 2003?
Offer a very short reply. 1.26. What is the ratio of the Emissions(in percent) in Slovenia in 1999 to that in 2003?
Ensure brevity in your answer.  1.1. What is the ratio of the Emissions(in percent) in United States in 1999 to that in 2003?
Your answer should be very brief. 0.98. What is the ratio of the Emissions(in percent) of Korea (Republic) in 1999 to that in 2004?
Provide a succinct answer. 1.25. What is the ratio of the Emissions(in percent) in New Caledonia in 1999 to that in 2004?
Your response must be concise. 1.25. What is the ratio of the Emissions(in percent) of Slovenia in 1999 to that in 2004?
Provide a succinct answer. 1.1. What is the ratio of the Emissions(in percent) in United States in 1999 to that in 2004?
Your answer should be very brief. 0.98. What is the ratio of the Emissions(in percent) of Korea (Republic) in 2000 to that in 2001?
Ensure brevity in your answer.  1.06. What is the ratio of the Emissions(in percent) in New Caledonia in 2000 to that in 2001?
Offer a terse response. 1.11. What is the ratio of the Emissions(in percent) of Slovenia in 2000 to that in 2001?
Ensure brevity in your answer.  1.01. What is the ratio of the Emissions(in percent) in United States in 2000 to that in 2001?
Provide a short and direct response. 0.98. What is the ratio of the Emissions(in percent) in Korea (Republic) in 2000 to that in 2002?
Your answer should be compact. 1.1. What is the ratio of the Emissions(in percent) of New Caledonia in 2000 to that in 2002?
Offer a very short reply. 1.01. What is the ratio of the Emissions(in percent) of Slovenia in 2000 to that in 2002?
Give a very brief answer. 1.06. What is the ratio of the Emissions(in percent) in Korea (Republic) in 2000 to that in 2003?
Ensure brevity in your answer.  1.15. What is the ratio of the Emissions(in percent) in New Caledonia in 2000 to that in 2003?
Keep it short and to the point. 1.01. What is the ratio of the Emissions(in percent) of Slovenia in 2000 to that in 2003?
Keep it short and to the point. 1.05. What is the ratio of the Emissions(in percent) of United States in 2000 to that in 2003?
Your answer should be compact. 0.97. What is the ratio of the Emissions(in percent) in Korea (Republic) in 2000 to that in 2004?
Offer a terse response. 1.18. What is the ratio of the Emissions(in percent) of New Caledonia in 2000 to that in 2004?
Ensure brevity in your answer.  1. What is the ratio of the Emissions(in percent) in Slovenia in 2000 to that in 2004?
Make the answer very short. 1.05. What is the ratio of the Emissions(in percent) in United States in 2000 to that in 2004?
Your answer should be very brief. 0.96. What is the ratio of the Emissions(in percent) in Korea (Republic) in 2001 to that in 2002?
Your response must be concise. 1.03. What is the ratio of the Emissions(in percent) of New Caledonia in 2001 to that in 2002?
Ensure brevity in your answer.  0.91. What is the ratio of the Emissions(in percent) of Slovenia in 2001 to that in 2002?
Provide a succinct answer. 1.05. What is the ratio of the Emissions(in percent) in United States in 2001 to that in 2002?
Make the answer very short. 1.02. What is the ratio of the Emissions(in percent) of Korea (Republic) in 2001 to that in 2003?
Your answer should be very brief. 1.08. What is the ratio of the Emissions(in percent) of New Caledonia in 2001 to that in 2003?
Provide a succinct answer. 0.91. What is the ratio of the Emissions(in percent) in Slovenia in 2001 to that in 2003?
Keep it short and to the point. 1.04. What is the ratio of the Emissions(in percent) in Korea (Republic) in 2001 to that in 2004?
Provide a succinct answer. 1.11. What is the ratio of the Emissions(in percent) in New Caledonia in 2001 to that in 2004?
Offer a terse response. 0.9. What is the ratio of the Emissions(in percent) of Slovenia in 2001 to that in 2004?
Offer a terse response. 1.04. What is the ratio of the Emissions(in percent) in United States in 2001 to that in 2004?
Your response must be concise. 0.99. What is the ratio of the Emissions(in percent) of Korea (Republic) in 2002 to that in 2003?
Give a very brief answer. 1.05. What is the ratio of the Emissions(in percent) in New Caledonia in 2002 to that in 2003?
Provide a succinct answer. 1. What is the ratio of the Emissions(in percent) in Slovenia in 2002 to that in 2003?
Offer a terse response. 0.99. What is the ratio of the Emissions(in percent) in United States in 2002 to that in 2003?
Ensure brevity in your answer.  0.97. What is the ratio of the Emissions(in percent) in Korea (Republic) in 2002 to that in 2004?
Provide a succinct answer. 1.08. What is the ratio of the Emissions(in percent) of New Caledonia in 2002 to that in 2004?
Ensure brevity in your answer.  0.99. What is the ratio of the Emissions(in percent) in United States in 2002 to that in 2004?
Provide a short and direct response. 0.97. What is the ratio of the Emissions(in percent) in Slovenia in 2003 to that in 2004?
Make the answer very short. 1. What is the ratio of the Emissions(in percent) of United States in 2003 to that in 2004?
Offer a very short reply. 0.99. What is the difference between the highest and the second highest Emissions(in percent) in Korea (Republic)?
Provide a succinct answer. 0.95. What is the difference between the highest and the second highest Emissions(in percent) of New Caledonia?
Offer a very short reply. 3.27. What is the difference between the highest and the second highest Emissions(in percent) of Slovenia?
Provide a short and direct response. 1.93. What is the difference between the highest and the second highest Emissions(in percent) of United States?
Make the answer very short. 0.29. What is the difference between the highest and the lowest Emissions(in percent) in Korea (Republic)?
Provide a short and direct response. 10.39. What is the difference between the highest and the lowest Emissions(in percent) of New Caledonia?
Make the answer very short. 24.05. What is the difference between the highest and the lowest Emissions(in percent) of Slovenia?
Provide a short and direct response. 4.85. What is the difference between the highest and the lowest Emissions(in percent) of United States?
Provide a short and direct response. 1.48. 